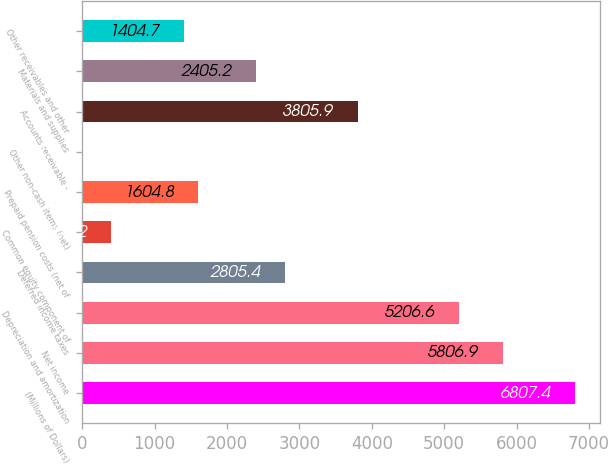Convert chart. <chart><loc_0><loc_0><loc_500><loc_500><bar_chart><fcel>(Millions of Dollars)<fcel>Net income<fcel>Depreciation and amortization<fcel>Deferred income taxes<fcel>Common equity component of<fcel>Prepaid pension costs (net of<fcel>Other non-cash items (net)<fcel>Accounts receivable -<fcel>Materials and supplies<fcel>Other receivables and other<nl><fcel>6807.4<fcel>5806.9<fcel>5206.6<fcel>2805.4<fcel>404.2<fcel>1604.8<fcel>4<fcel>3805.9<fcel>2405.2<fcel>1404.7<nl></chart> 